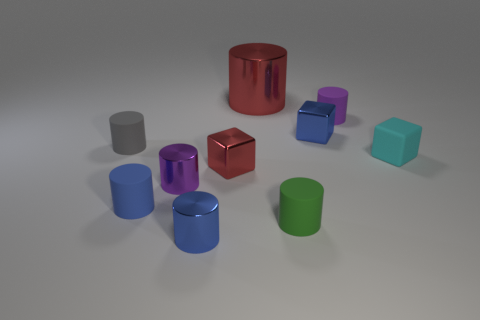Subtract all gray cylinders. How many cylinders are left? 6 Subtract 1 cylinders. How many cylinders are left? 6 Subtract all small blue cylinders. How many cylinders are left? 5 Subtract all gray cylinders. Subtract all yellow spheres. How many cylinders are left? 6 Subtract all blocks. How many objects are left? 7 Subtract 0 brown cubes. How many objects are left? 10 Subtract all small blue rubber cylinders. Subtract all large brown rubber cylinders. How many objects are left? 9 Add 9 gray cylinders. How many gray cylinders are left? 10 Add 3 green objects. How many green objects exist? 4 